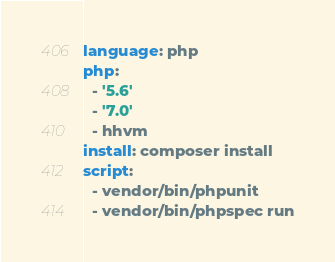<code> <loc_0><loc_0><loc_500><loc_500><_YAML_>language: php
php:
  - '5.6'
  - '7.0'
  - hhvm
install: composer install
script:
  - vendor/bin/phpunit
  - vendor/bin/phpspec run
</code> 